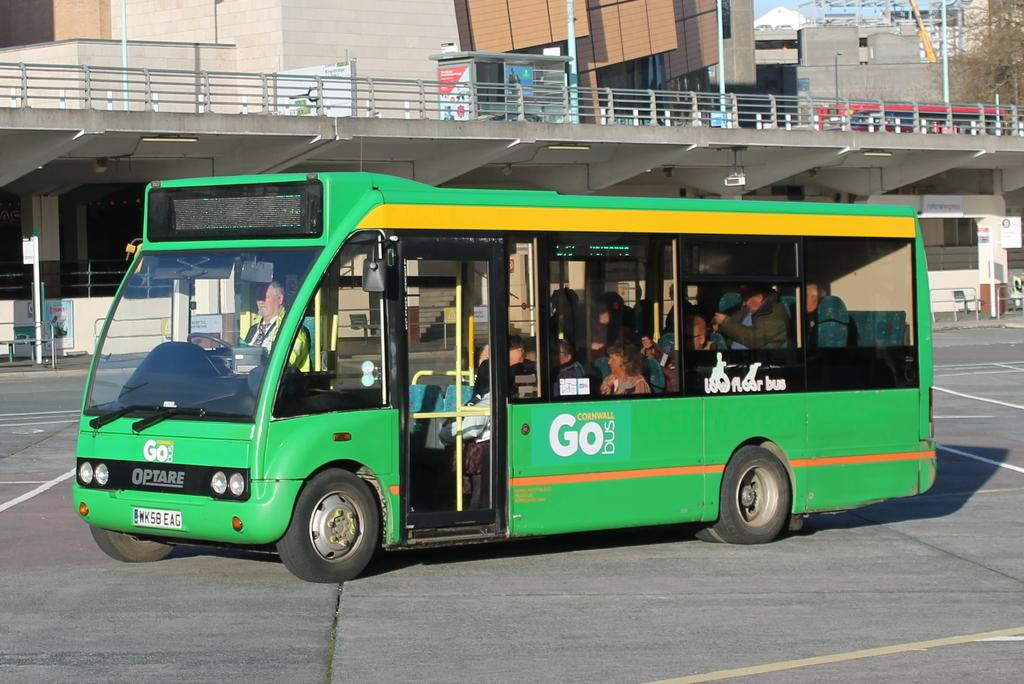<image>
Render a clear and concise summary of the photo. A green bus with the word Go on the left side 